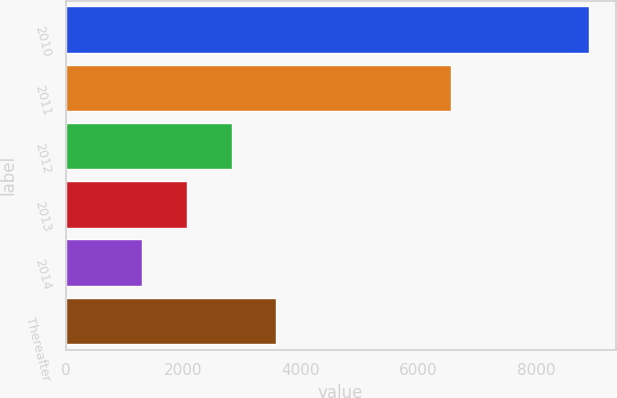Convert chart to OTSL. <chart><loc_0><loc_0><loc_500><loc_500><bar_chart><fcel>2010<fcel>2011<fcel>2012<fcel>2013<fcel>2014<fcel>Thereafter<nl><fcel>8910<fcel>6563<fcel>2824.4<fcel>2063.7<fcel>1303<fcel>3585.1<nl></chart> 